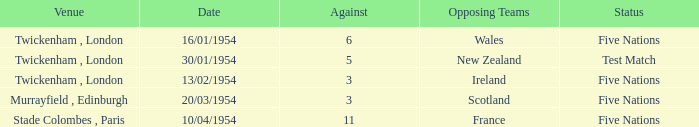What was the venue for the game played on 16/01/1954, when the against was more than 3? Twickenham , London. 